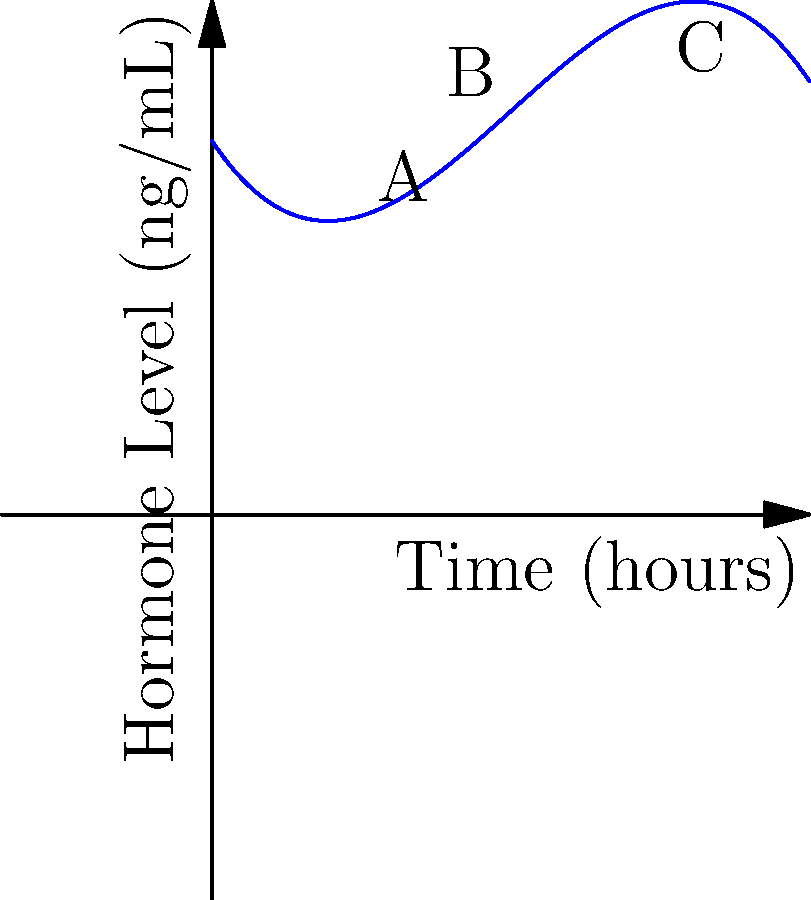A hormone replacement therapy medication is administered to a patient. The graph shows the hormone level in the bloodstream over time. At which point (A, B, or C) is the rate of change of the hormone level closest to zero, indicating a potential optimal dosing interval? To determine where the rate of change is closest to zero, we need to analyze the slope of the curve at each point:

1. Point A (around 2 hours): The curve is rising steeply, indicating a rapid increase in hormone levels. The slope is clearly positive and not close to zero.

2. Point B (around 4 hours): This appears to be near the peak of the curve. The slope is transitioning from positive to negative, passing through zero at the exact peak.

3. Point C (around 6 hours): The curve is decreasing, but less steeply than it was increasing at point A. The slope is negative but smaller in magnitude than at point A.

The rate of change is represented by the slope of the tangent line at each point. The slope is closest to zero where the curve is flattest, which occurs at the peak of the curve.

Point B is located near this peak, where the curve transitions from increasing to decreasing. This is where the slope (rate of change) would be closest to zero.

Therefore, point B represents the location where the rate of change of the hormone level is closest to zero, indicating a potential optimal dosing interval.
Answer: B 